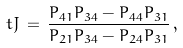Convert formula to latex. <formula><loc_0><loc_0><loc_500><loc_500>\ t J \, = \, \frac { P _ { 4 1 } P _ { 3 4 } - P _ { 4 4 } P _ { 3 1 } } { P _ { 2 1 } P _ { 3 4 } - P _ { 2 4 } P _ { 3 1 } } \, ,</formula> 